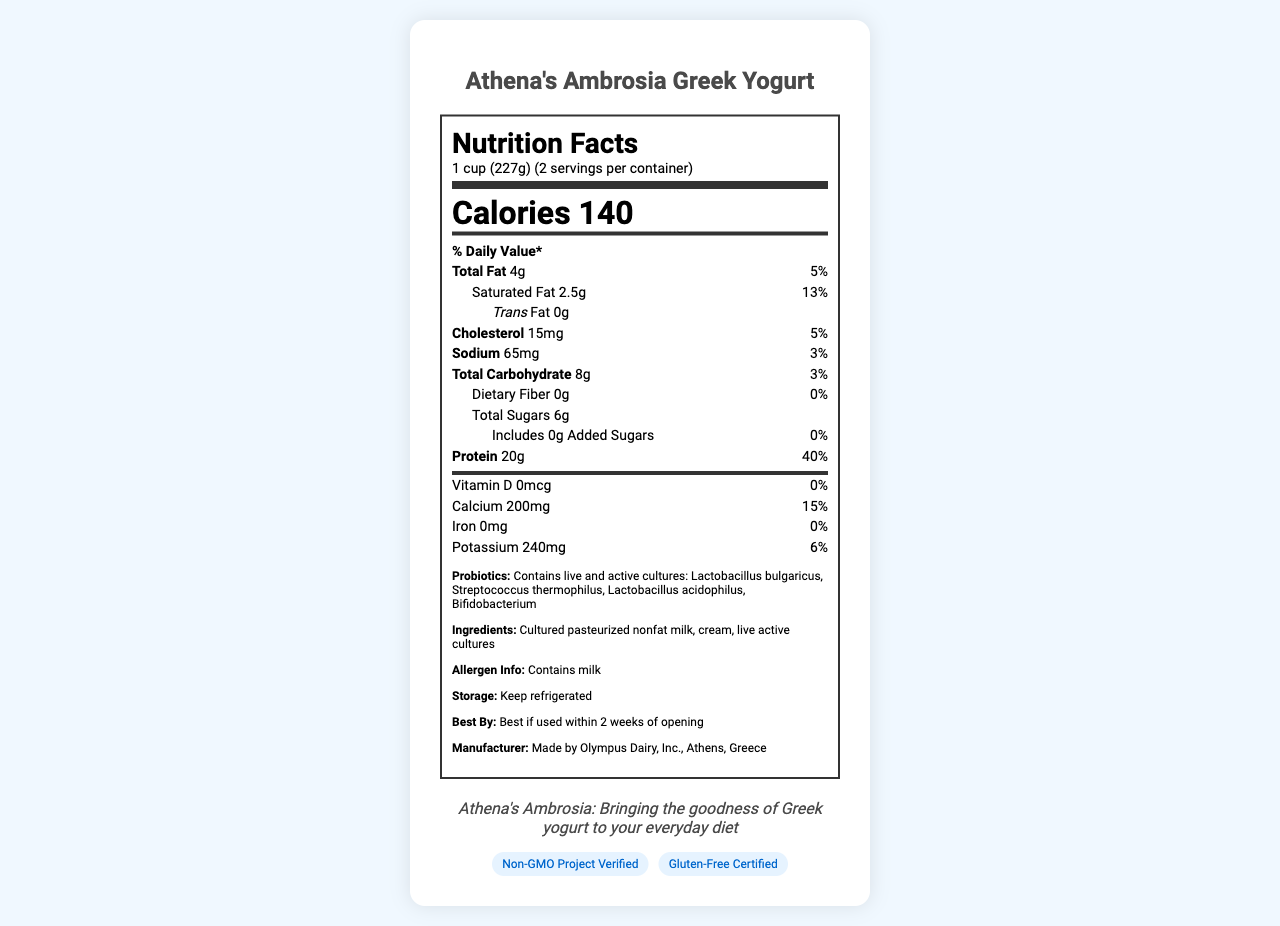what is the serving size for Athena's Ambrosia Greek Yogurt? The serving size is clearly mentioned as 1 cup (227g) in the document.
Answer: 1 cup (227g) how many servings are there per container? The document specifies that there are 2 servings per container.
Answer: 2 servings how many calories are there per serving? The number of calories per serving is indicated as 140 on the document.
Answer: 140 calories what is the amount of protein per serving? The protein content per serving is listed as 20g on the document.
Answer: 20g what is the percentage of daily value for calcium? The percentage daily value for calcium is given as 15% in the document.
Answer: 15% Athena's Ambrosia Greek Yogurt contains which probiotic cultures? A. Lactobacillus bulgaricus and Streptococcus thermophilus B. Bifidobacterium and Lactobacillus acidophilus C. Both A and B D. None of the above The document lists that the yogurt contains Lactobacillus bulgaricus, Streptococcus thermophilus, Lactobacillus acidophilus, and Bifidobacterium.
Answer: C what is the amount of total sugars per serving? A. 6g B. 8g C. 4g D. 10g The document mentions that the amount of total sugars per serving is 6g.
Answer: A does the yogurt contain any dietary fiber? The document states that the dietary fiber content is 0g.
Answer: No is Athena's Ambrosia Greek Yogurt gluten-free? The document includes a certification stating that the yogurt is Gluten-Free Certified.
Answer: Yes is there any information about vitamin C in the yogurt? The document does not mention any details about vitamin C content, indicating there is no available information.
Answer: No describe the main idea of the document. The explanation covers all key aspects mentioned in the document such as nutritional details, probiotic cultures, and additional product information.
Answer: The document provides detailed nutritional information about Athena's Ambrosia Greek Yogurt, including serving size, calorie content, macronutrient breakdown, vitamins, minerals, probiotic cultures, ingredients, allergen information, storage instructions, expiration, and certifications. 